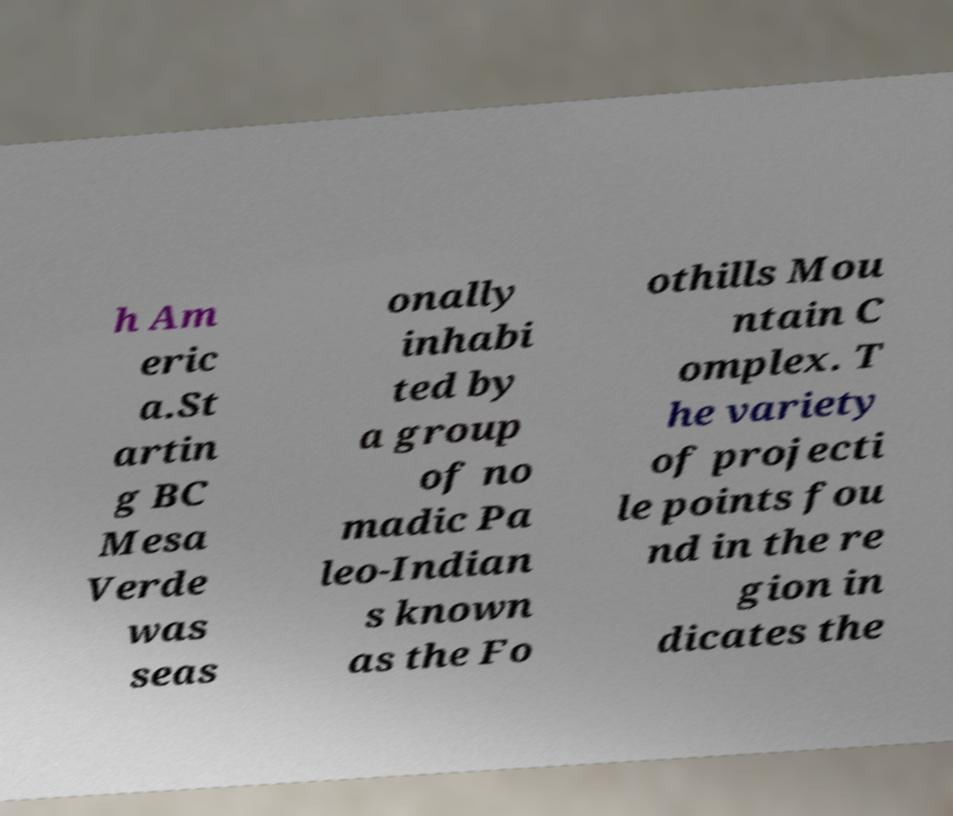There's text embedded in this image that I need extracted. Can you transcribe it verbatim? h Am eric a.St artin g BC Mesa Verde was seas onally inhabi ted by a group of no madic Pa leo-Indian s known as the Fo othills Mou ntain C omplex. T he variety of projecti le points fou nd in the re gion in dicates the 